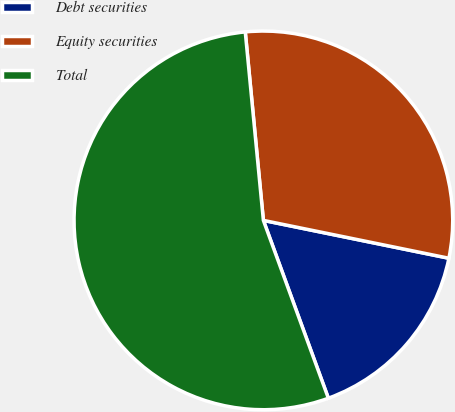<chart> <loc_0><loc_0><loc_500><loc_500><pie_chart><fcel>Debt securities<fcel>Equity securities<fcel>Total<nl><fcel>16.22%<fcel>29.73%<fcel>54.05%<nl></chart> 